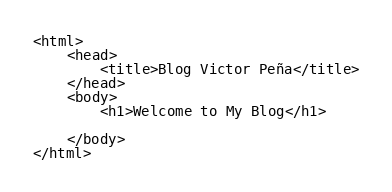<code> <loc_0><loc_0><loc_500><loc_500><_HTML_><html>
    <head>
        <title>Blog Victor Peña</title>
    </head>
    <body>
        <h1>Welcome to My Blog</h1>

    </body>
</html>
</code> 